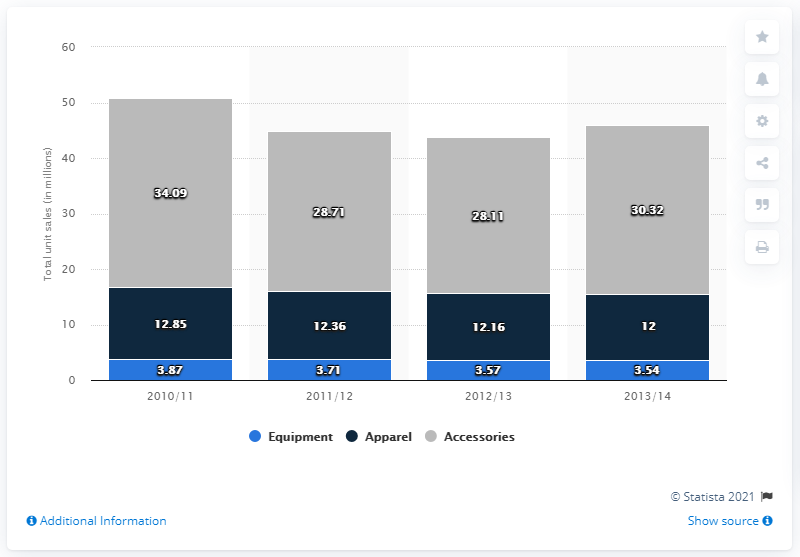Highlight a few significant elements in this photo. During the 2010/11 snow sports season in the US, a total of 34,090 units of snow sports accessories were sold. 